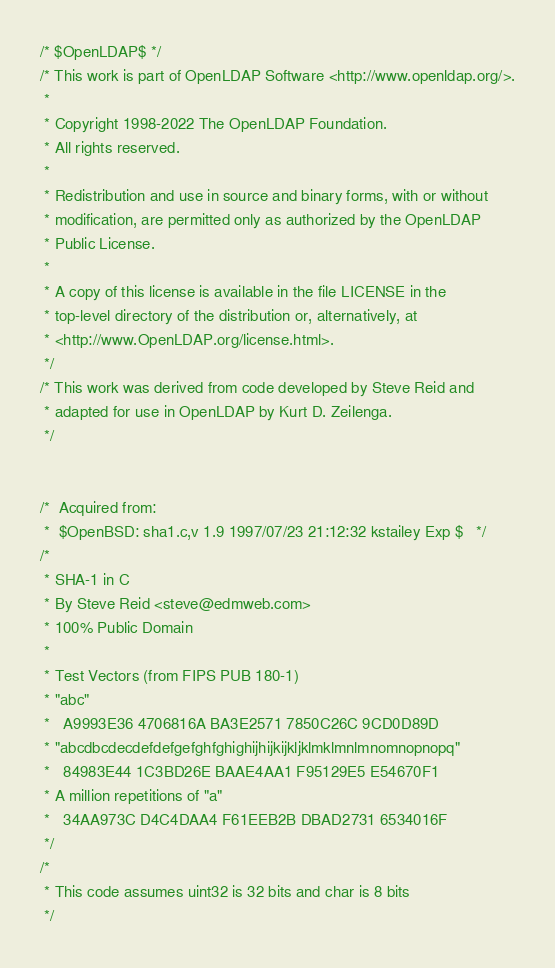Convert code to text. <code><loc_0><loc_0><loc_500><loc_500><_C_>/* $OpenLDAP$ */
/* This work is part of OpenLDAP Software <http://www.openldap.org/>.
 *
 * Copyright 1998-2022 The OpenLDAP Foundation.
 * All rights reserved.
 *
 * Redistribution and use in source and binary forms, with or without
 * modification, are permitted only as authorized by the OpenLDAP
 * Public License.
 *
 * A copy of this license is available in the file LICENSE in the
 * top-level directory of the distribution or, alternatively, at
 * <http://www.OpenLDAP.org/license.html>.
 */
/* This work was derived from code developed by Steve Reid and
 * adapted for use in OpenLDAP by Kurt D. Zeilenga.
 */


/*	Acquired from:
 *	$OpenBSD: sha1.c,v 1.9 1997/07/23 21:12:32 kstailey Exp $	*/
/*
 * SHA-1 in C
 * By Steve Reid <steve@edmweb.com>
 * 100% Public Domain
 *
 * Test Vectors (from FIPS PUB 180-1)
 * "abc"
 *   A9993E36 4706816A BA3E2571 7850C26C 9CD0D89D
 * "abcdbcdecdefdefgefghfghighijhijkijkljklmklmnlmnomnopnopq"
 *   84983E44 1C3BD26E BAAE4AA1 F95129E5 E54670F1
 * A million repetitions of "a"
 *   34AA973C D4C4DAA4 F61EEB2B DBAD2731 6534016F
 */
/*
 * This code assumes uint32 is 32 bits and char is 8 bits
 */
</code> 